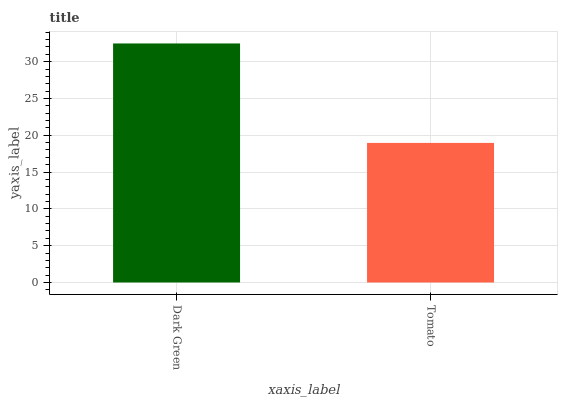Is Tomato the minimum?
Answer yes or no. Yes. Is Dark Green the maximum?
Answer yes or no. Yes. Is Tomato the maximum?
Answer yes or no. No. Is Dark Green greater than Tomato?
Answer yes or no. Yes. Is Tomato less than Dark Green?
Answer yes or no. Yes. Is Tomato greater than Dark Green?
Answer yes or no. No. Is Dark Green less than Tomato?
Answer yes or no. No. Is Dark Green the high median?
Answer yes or no. Yes. Is Tomato the low median?
Answer yes or no. Yes. Is Tomato the high median?
Answer yes or no. No. Is Dark Green the low median?
Answer yes or no. No. 